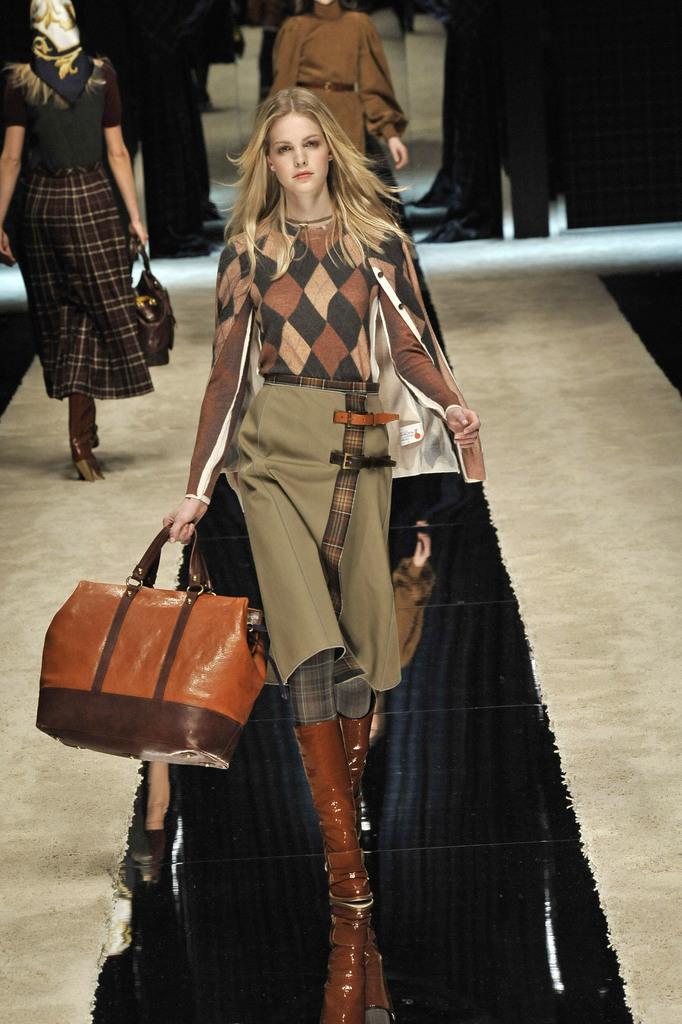Describe this image in one or two sentences. In the image we can see there is a woman who is standing on the stage and holding a bag and at the back there are lot of woman standing. 